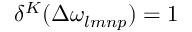Convert formula to latex. <formula><loc_0><loc_0><loc_500><loc_500>\delta ^ { K } ( \Delta \omega _ { l m n p } ) = 1</formula> 